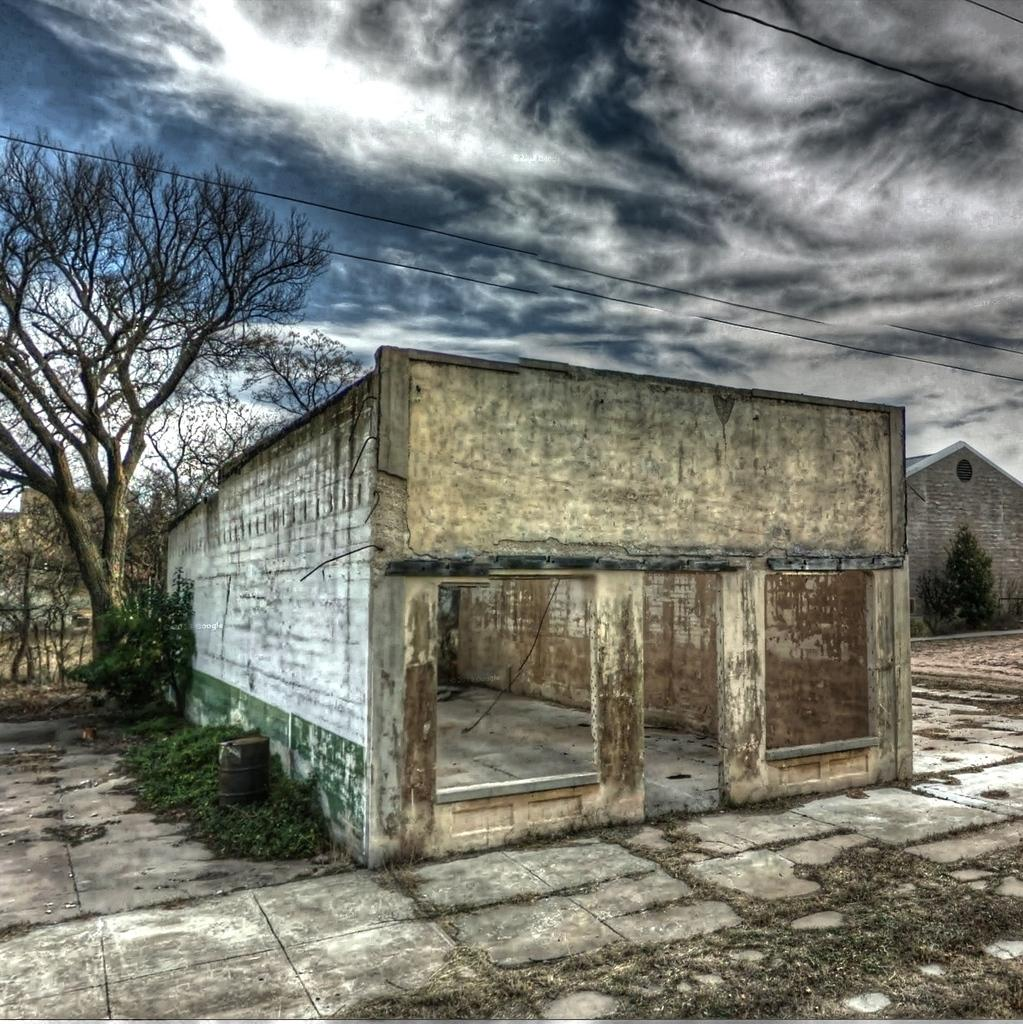What is the condition of the sky in the image? The sky is cloudy in the image. What type of structures can be seen in the image? There are buildings in the image. What type of vegetation is present in the image? There are plants and trees in the image. What object related to music can be seen in the image? There is a drum in the image. How many beds are visible in the image? There are no beds present in the image. What type of yard can be seen in the image? There is no yard present in the image. 